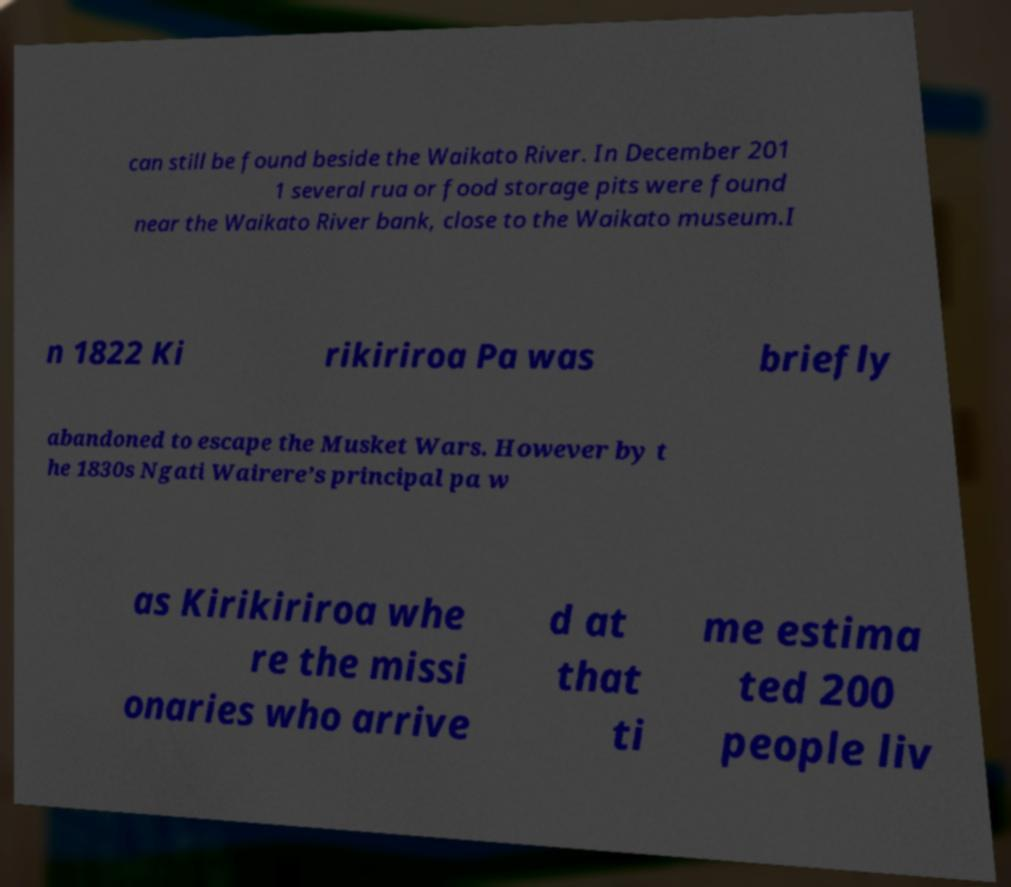Please read and relay the text visible in this image. What does it say? can still be found beside the Waikato River. In December 201 1 several rua or food storage pits were found near the Waikato River bank, close to the Waikato museum.I n 1822 Ki rikiriroa Pa was briefly abandoned to escape the Musket Wars. However by t he 1830s Ngati Wairere’s principal pa w as Kirikiriroa whe re the missi onaries who arrive d at that ti me estima ted 200 people liv 